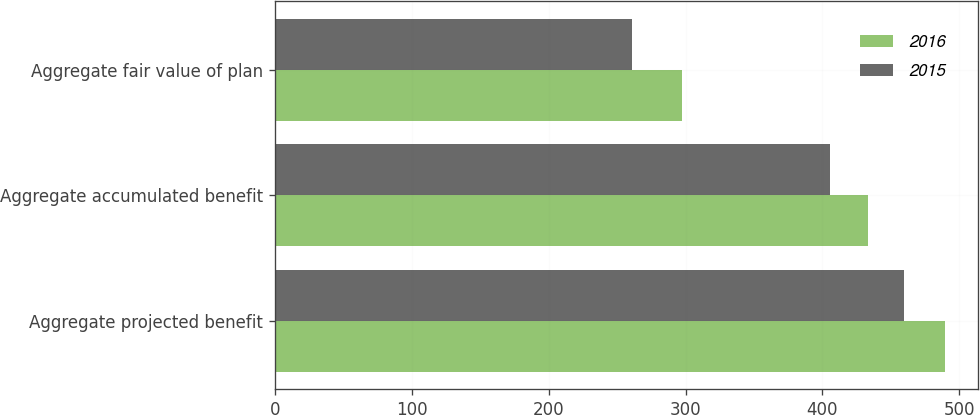Convert chart to OTSL. <chart><loc_0><loc_0><loc_500><loc_500><stacked_bar_chart><ecel><fcel>Aggregate projected benefit<fcel>Aggregate accumulated benefit<fcel>Aggregate fair value of plan<nl><fcel>2016<fcel>489.5<fcel>433.1<fcel>297.1<nl><fcel>2015<fcel>459.2<fcel>405.3<fcel>260.9<nl></chart> 